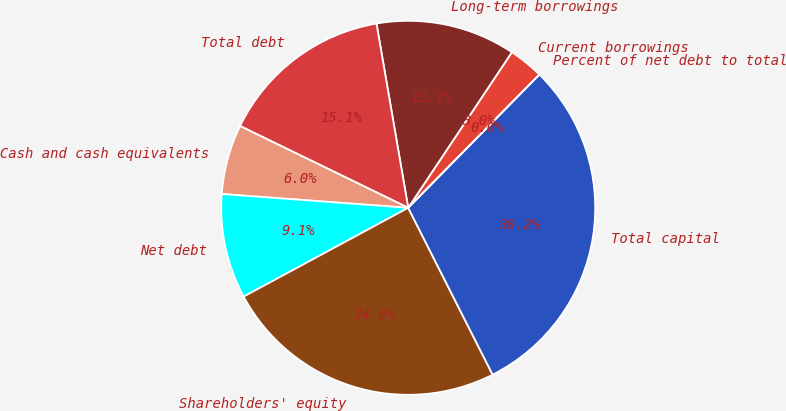Convert chart to OTSL. <chart><loc_0><loc_0><loc_500><loc_500><pie_chart><fcel>Current borrowings<fcel>Long-term borrowings<fcel>Total debt<fcel>Less Cash and cash equivalents<fcel>Net debt<fcel>Shareholders' equity<fcel>Total capital<fcel>Percent of net debt to total<nl><fcel>3.02%<fcel>12.07%<fcel>15.08%<fcel>6.03%<fcel>9.05%<fcel>24.58%<fcel>30.17%<fcel>0.0%<nl></chart> 